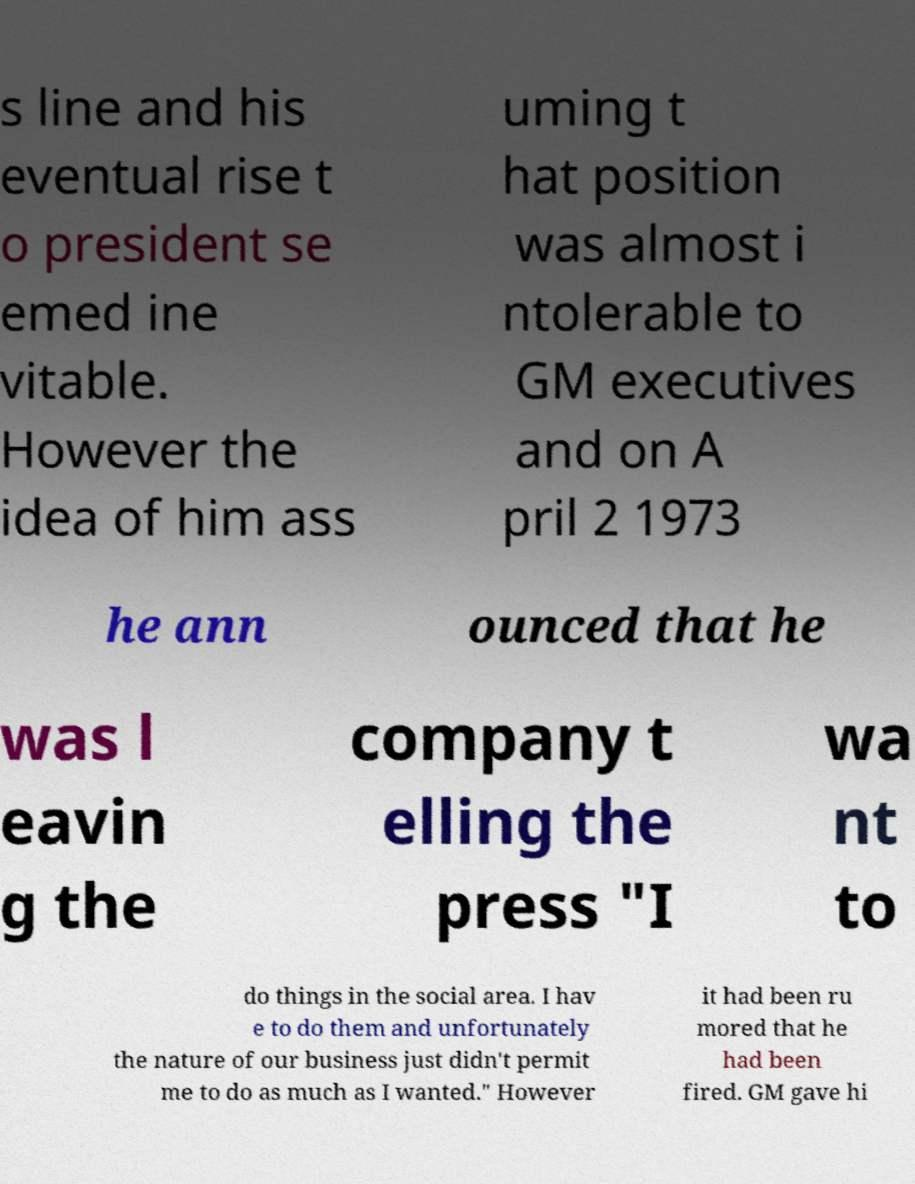I need the written content from this picture converted into text. Can you do that? s line and his eventual rise t o president se emed ine vitable. However the idea of him ass uming t hat position was almost i ntolerable to GM executives and on A pril 2 1973 he ann ounced that he was l eavin g the company t elling the press "I wa nt to do things in the social area. I hav e to do them and unfortunately the nature of our business just didn't permit me to do as much as I wanted." However it had been ru mored that he had been fired. GM gave hi 